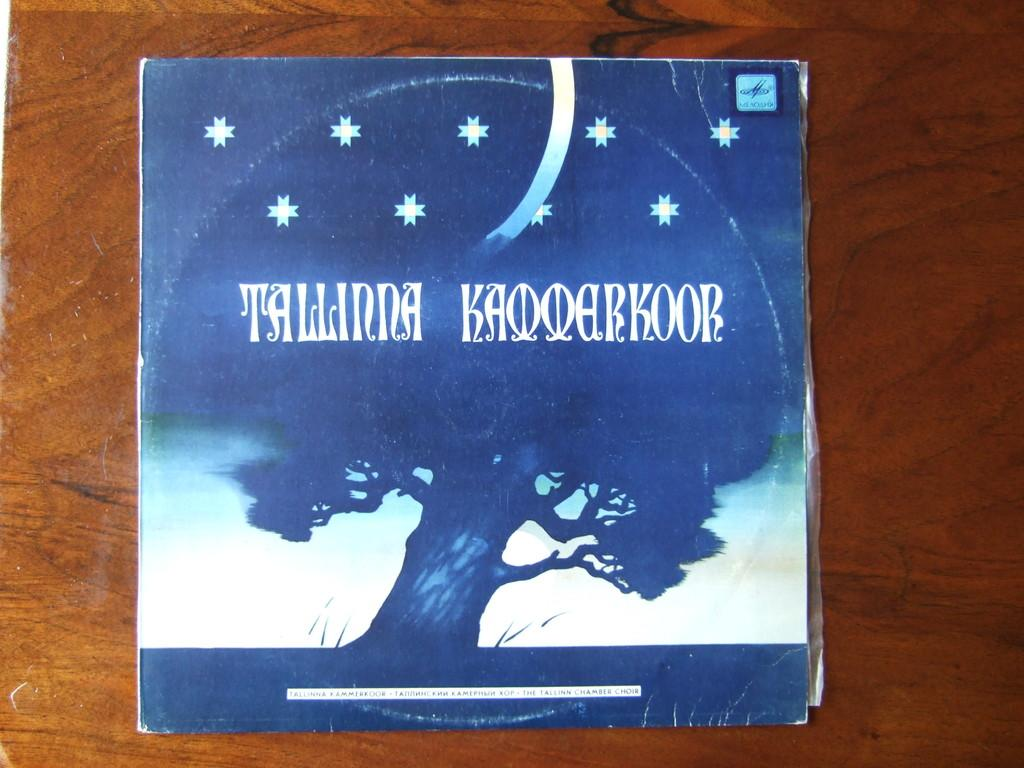<image>
Give a short and clear explanation of the subsequent image. A book on a table called Tallinna Kaooarkoor with a tree covering the front of the book. 